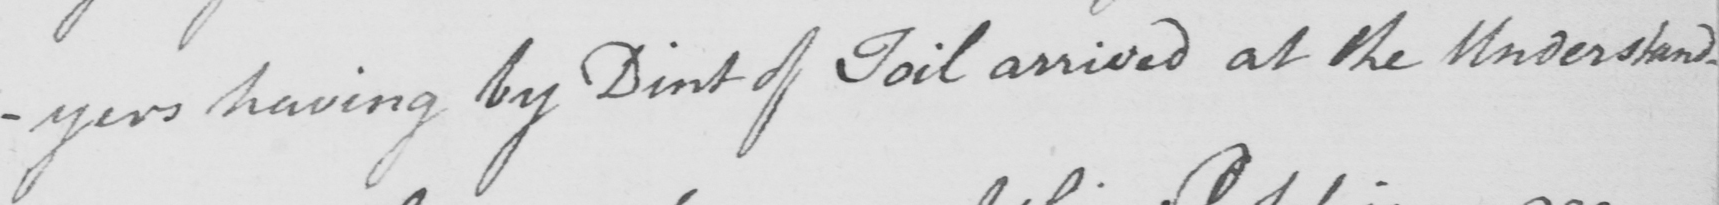What text is written in this handwritten line? -yers having by Dint of Toil arrived at the Understand- 